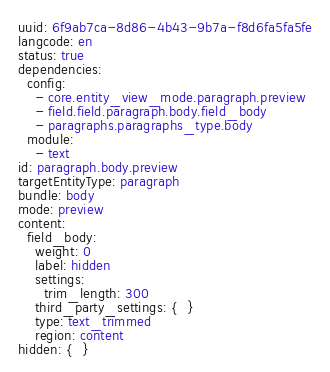Convert code to text. <code><loc_0><loc_0><loc_500><loc_500><_YAML_>uuid: 6f9ab7ca-8d86-4b43-9b7a-f8d6fa5fa5fe
langcode: en
status: true
dependencies:
  config:
    - core.entity_view_mode.paragraph.preview
    - field.field.paragraph.body.field_body
    - paragraphs.paragraphs_type.body
  module:
    - text
id: paragraph.body.preview
targetEntityType: paragraph
bundle: body
mode: preview
content:
  field_body:
    weight: 0
    label: hidden
    settings:
      trim_length: 300
    third_party_settings: {  }
    type: text_trimmed
    region: content
hidden: {  }
</code> 